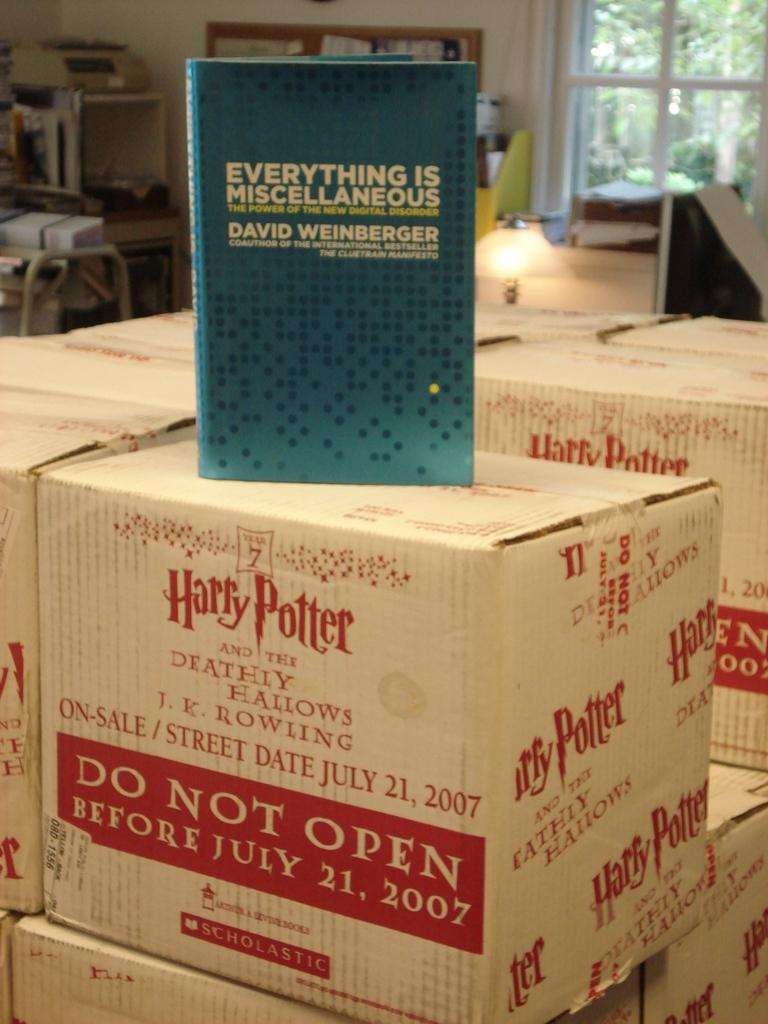<image>
Present a compact description of the photo's key features. Stacks of boxes of Harry Potter books sit in the office. 